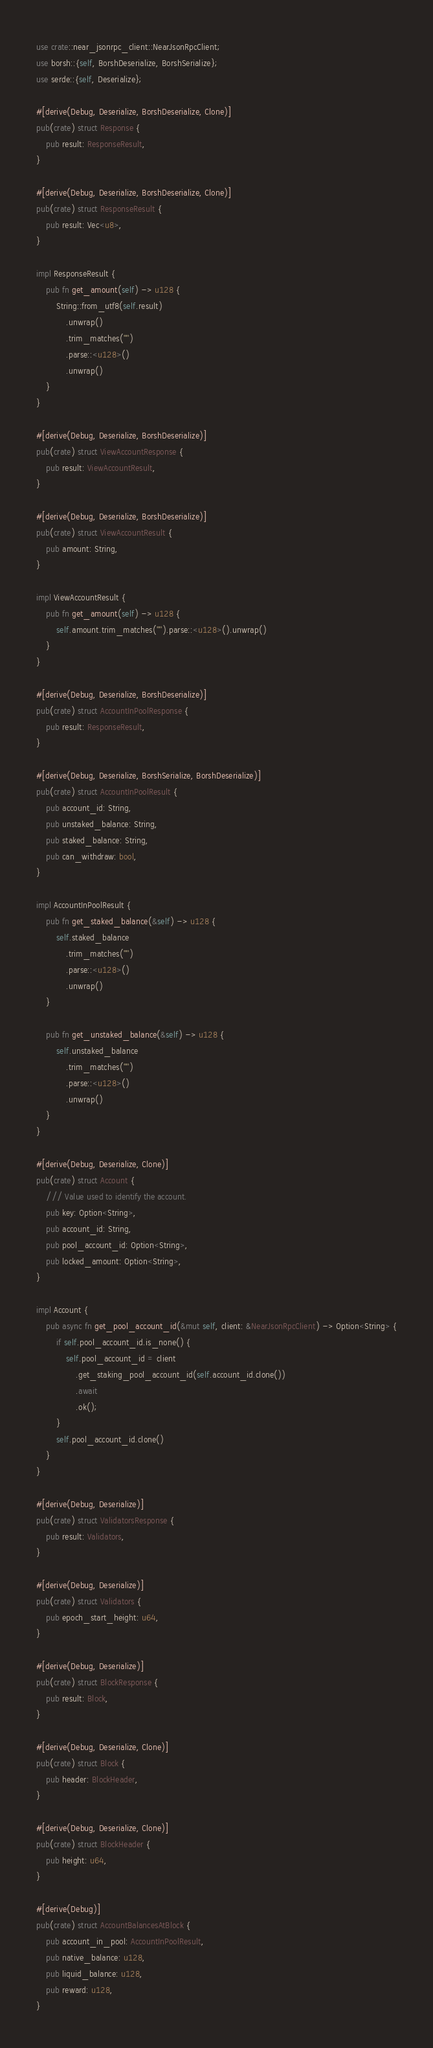<code> <loc_0><loc_0><loc_500><loc_500><_Rust_>use crate::near_jsonrpc_client::NearJsonRpcClient;
use borsh::{self, BorshDeserialize, BorshSerialize};
use serde::{self, Deserialize};

#[derive(Debug, Deserialize, BorshDeserialize, Clone)]
pub(crate) struct Response {
    pub result: ResponseResult,
}

#[derive(Debug, Deserialize, BorshDeserialize, Clone)]
pub(crate) struct ResponseResult {
    pub result: Vec<u8>,
}

impl ResponseResult {
    pub fn get_amount(self) -> u128 {
        String::from_utf8(self.result)
            .unwrap()
            .trim_matches('"')
            .parse::<u128>()
            .unwrap()
    }
}

#[derive(Debug, Deserialize, BorshDeserialize)]
pub(crate) struct ViewAccountResponse {
    pub result: ViewAccountResult,
}

#[derive(Debug, Deserialize, BorshDeserialize)]
pub(crate) struct ViewAccountResult {
    pub amount: String,
}

impl ViewAccountResult {
    pub fn get_amount(self) -> u128 {
        self.amount.trim_matches('"').parse::<u128>().unwrap()
    }
}

#[derive(Debug, Deserialize, BorshDeserialize)]
pub(crate) struct AccountInPoolResponse {
    pub result: ResponseResult,
}

#[derive(Debug, Deserialize, BorshSerialize, BorshDeserialize)]
pub(crate) struct AccountInPoolResult {
    pub account_id: String,
    pub unstaked_balance: String,
    pub staked_balance: String,
    pub can_withdraw: bool,
}

impl AccountInPoolResult {
    pub fn get_staked_balance(&self) -> u128 {
        self.staked_balance
            .trim_matches('"')
            .parse::<u128>()
            .unwrap()
    }

    pub fn get_unstaked_balance(&self) -> u128 {
        self.unstaked_balance
            .trim_matches('"')
            .parse::<u128>()
            .unwrap()
    }
}

#[derive(Debug, Deserialize, Clone)]
pub(crate) struct Account {
    /// Value used to identify the account.
    pub key: Option<String>,
    pub account_id: String,
    pub pool_account_id: Option<String>,
    pub locked_amount: Option<String>,
}

impl Account {
    pub async fn get_pool_account_id(&mut self, client: &NearJsonRpcClient) -> Option<String> {
        if self.pool_account_id.is_none() {
            self.pool_account_id = client
                .get_staking_pool_account_id(self.account_id.clone())
                .await
                .ok();
        }
        self.pool_account_id.clone()
    }
}

#[derive(Debug, Deserialize)]
pub(crate) struct ValidatorsResponse {
    pub result: Validators,
}

#[derive(Debug, Deserialize)]
pub(crate) struct Validators {
    pub epoch_start_height: u64,
}

#[derive(Debug, Deserialize)]
pub(crate) struct BlockResponse {
    pub result: Block,
}

#[derive(Debug, Deserialize, Clone)]
pub(crate) struct Block {
    pub header: BlockHeader,
}

#[derive(Debug, Deserialize, Clone)]
pub(crate) struct BlockHeader {
    pub height: u64,
}

#[derive(Debug)]
pub(crate) struct AccountBalancesAtBlock {
    pub account_in_pool: AccountInPoolResult,
    pub native_balance: u128,
    pub liquid_balance: u128,
    pub reward: u128,
}
</code> 